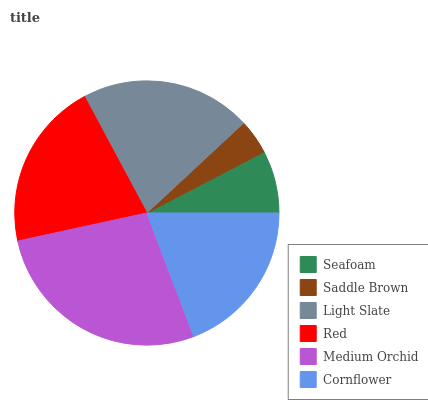Is Saddle Brown the minimum?
Answer yes or no. Yes. Is Medium Orchid the maximum?
Answer yes or no. Yes. Is Light Slate the minimum?
Answer yes or no. No. Is Light Slate the maximum?
Answer yes or no. No. Is Light Slate greater than Saddle Brown?
Answer yes or no. Yes. Is Saddle Brown less than Light Slate?
Answer yes or no. Yes. Is Saddle Brown greater than Light Slate?
Answer yes or no. No. Is Light Slate less than Saddle Brown?
Answer yes or no. No. Is Red the high median?
Answer yes or no. Yes. Is Cornflower the low median?
Answer yes or no. Yes. Is Light Slate the high median?
Answer yes or no. No. Is Seafoam the low median?
Answer yes or no. No. 